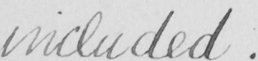Can you tell me what this handwritten text says? included . 